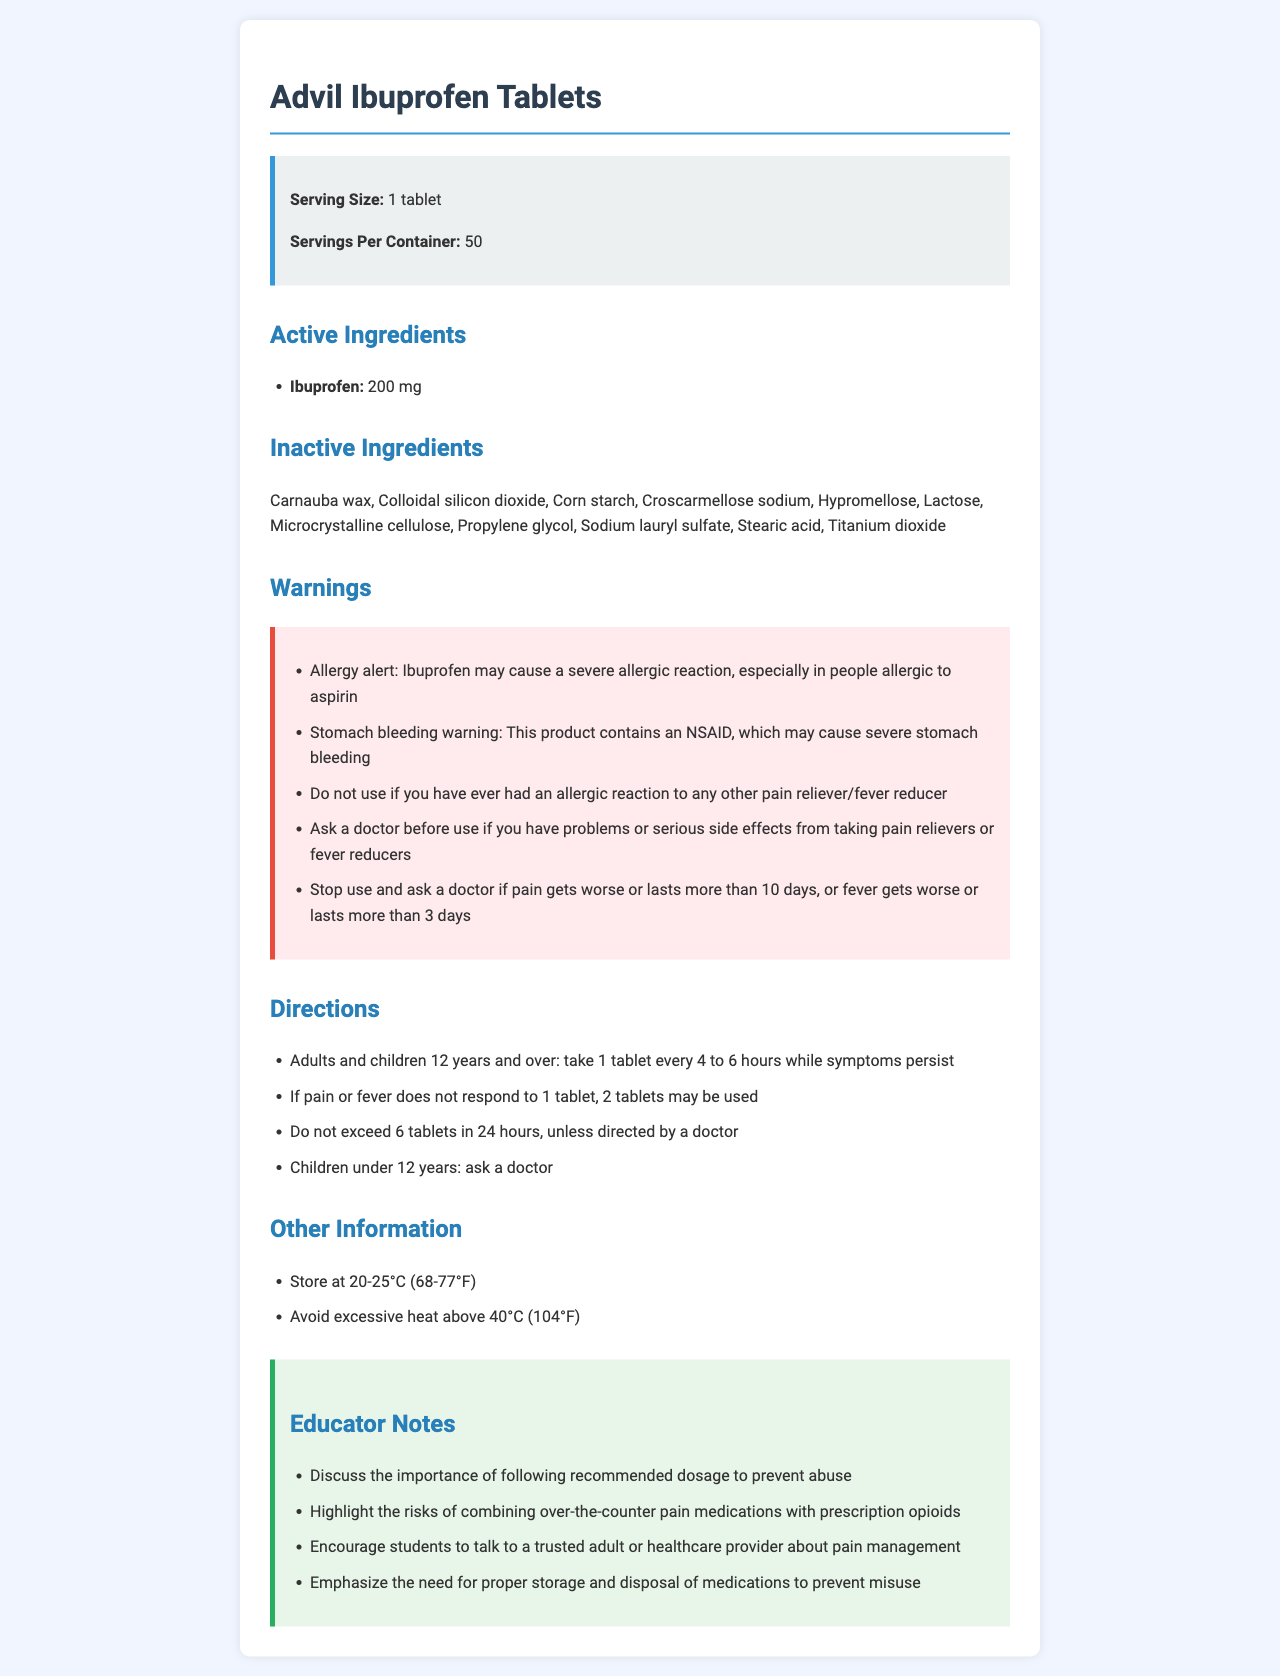what is the active ingredient in Advil Ibuprofen Tablets? The document specifically lists Ibuprofen as the active ingredient, with an amount of 200 mg per tablet.
Answer: Ibuprofen what is the maximum number of tablets an adult can take in 24 hours? According to the directions, adults should not exceed 6 tablets in 24 hours unless directed by a doctor.
Answer: 6 tablets name three inactive ingredients in this medication. The document lists several inactive ingredients, including Carnauba wax, Colloidal silicon dioxide, and Corn starch.
Answer: Carnauba wax, Colloidal silicon dioxide, Corn starch why should a person ask a doctor before using this medication if they have had problems with pain relievers before? The document mentions a warning to ask a doctor before use if you have problems or serious side effects from taking pain relievers or fever reducers.
Answer: Due to serious side effects from taking pain relievers or fever reducers what should someone do if their pain lasts more than 10 days while using this medication? The warnings section advises stopping use and asking a doctor if pain gets worse or lasts more than 10 days.
Answer: Stop use and ask a doctor what is the serving size of Advil Ibuprofen Tablets? A. 2 tablets B. 1 tablet C. 3 tablets D. 4 tablets The serving size is stated as 1 tablet in the document.
Answer: B. 1 tablet which of the following is an allergy alert given in the document? A. May cause drowsiness B. May cause a skin rash C. May cause a severe allergic reaction, especially in people allergic to aspirin D. May cause headaches The allergy alert section includes a warning that Ibuprofen may cause a severe allergic reaction, especially in those allergic to aspirin.
Answer: C. May cause a severe allergic reaction, especially in people allergic to aspirin should children under 12 use Advil Ibuprofen Tablets without consulting a doctor? The directions state that children under 12 years should ask a doctor before using this medication.
Answer: No can this medication be stored at 30°C (86°F)? The other information section advises storing at 20-25°C (68-77°F) but does not prohibit storage at 30°C, so it falls within acceptable limits.
Answer: Yes summarize the main warnings provided for Advil Ibuprofen Tablets. The warnings cover an allergy alert for those allergic to aspirin, a warning about severe stomach bleeding due to the NSAID content, and advice to stop use if pain or fever persists beyond specified durations.
Answer: Allergy alert, stomach bleeding warning, and stop use if pain worsens or lasts more than 10 days what is the role of croscarmellose sodium in the medication? The document does not provide information on the specific roles of the inactive ingredients, including croscarmellose sodium.
Answer: Cannot be determined 